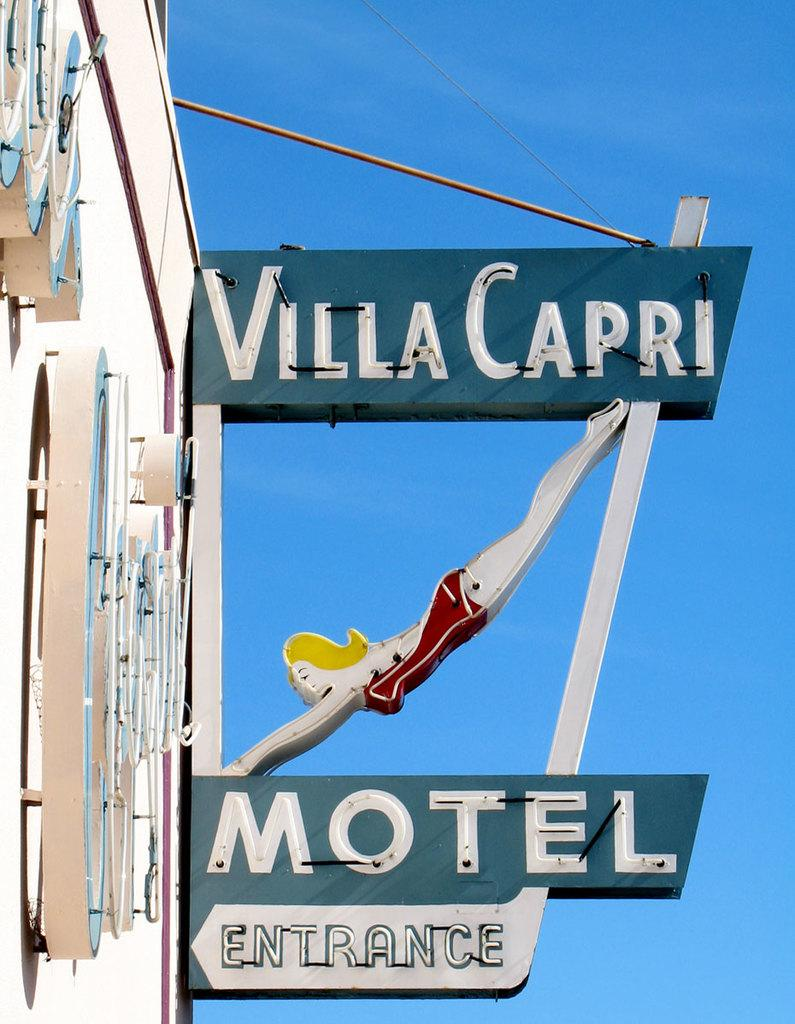<image>
Give a short and clear explanation of the subsequent image. motel sign that reads villa capri and in blue 